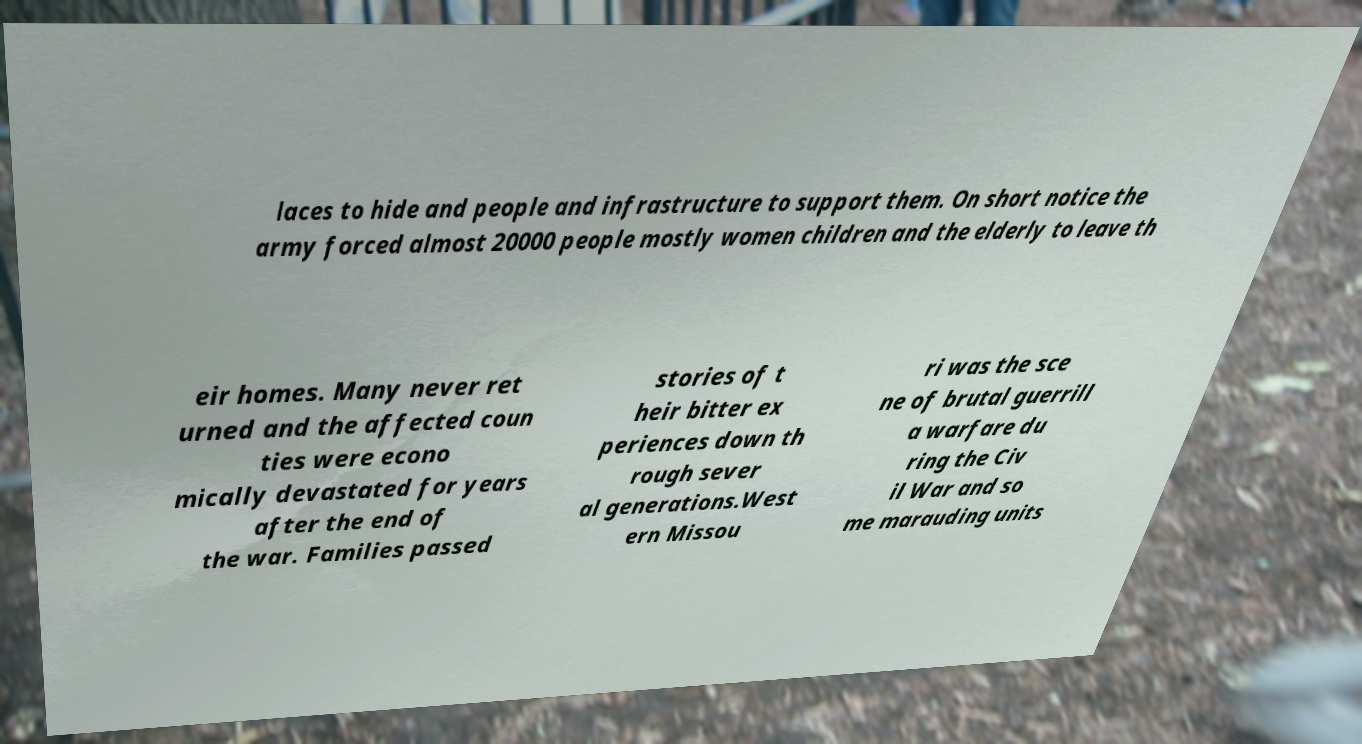There's text embedded in this image that I need extracted. Can you transcribe it verbatim? laces to hide and people and infrastructure to support them. On short notice the army forced almost 20000 people mostly women children and the elderly to leave th eir homes. Many never ret urned and the affected coun ties were econo mically devastated for years after the end of the war. Families passed stories of t heir bitter ex periences down th rough sever al generations.West ern Missou ri was the sce ne of brutal guerrill a warfare du ring the Civ il War and so me marauding units 